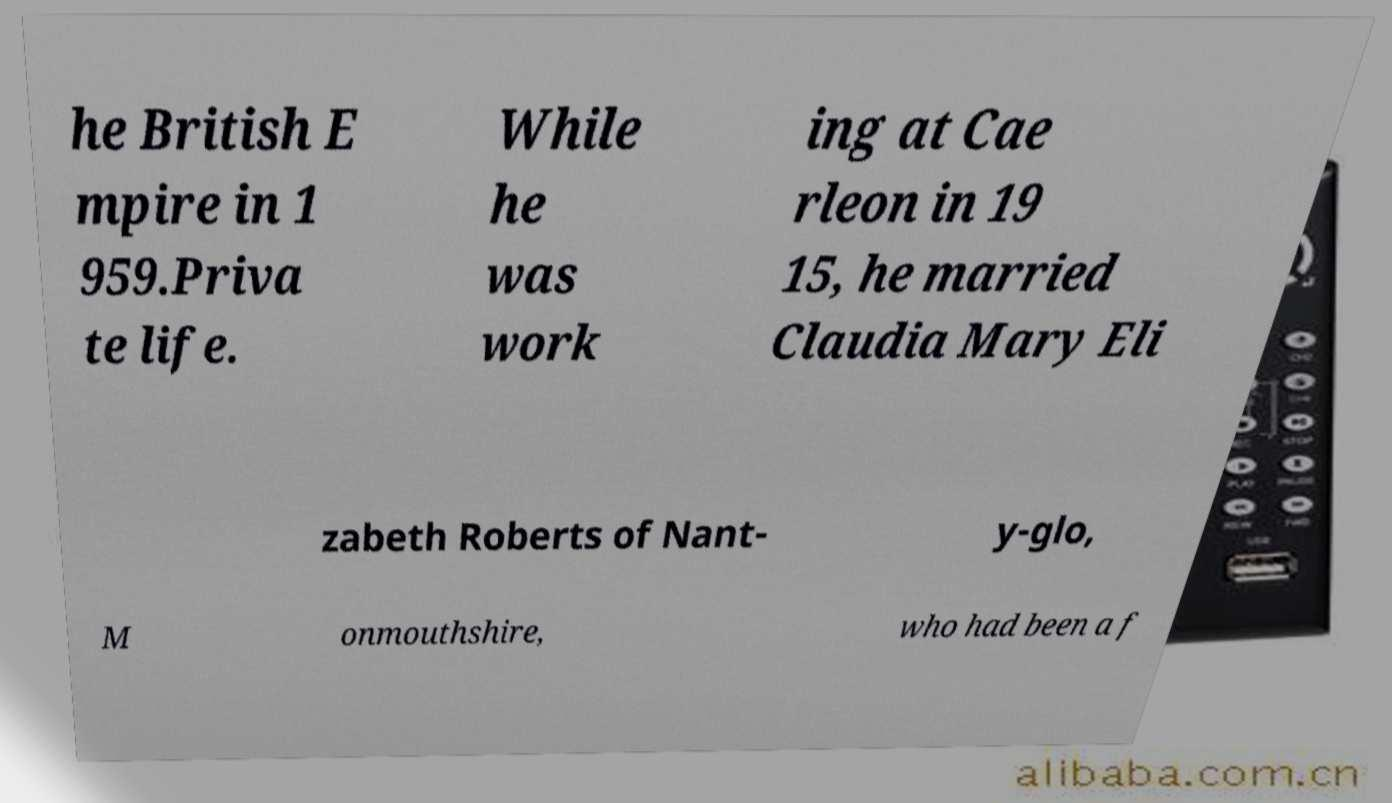Could you assist in decoding the text presented in this image and type it out clearly? he British E mpire in 1 959.Priva te life. While he was work ing at Cae rleon in 19 15, he married Claudia Mary Eli zabeth Roberts of Nant- y-glo, M onmouthshire, who had been a f 